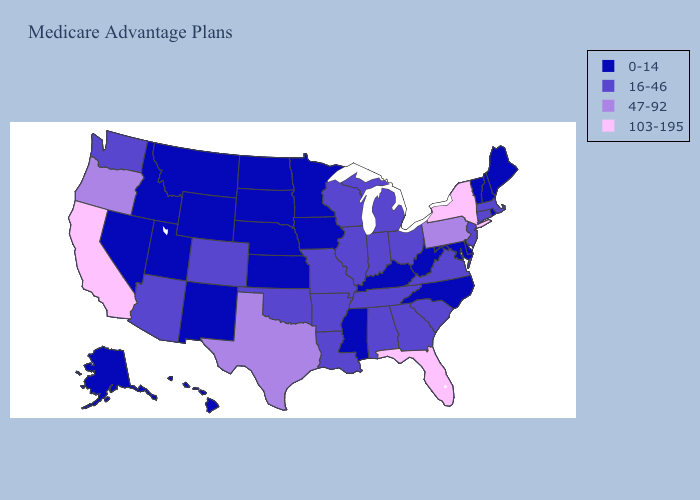Name the states that have a value in the range 103-195?
Answer briefly. California, Florida, New York. Among the states that border Minnesota , does Wisconsin have the highest value?
Answer briefly. Yes. What is the highest value in the USA?
Quick response, please. 103-195. Does Michigan have the lowest value in the USA?
Quick response, please. No. Does the first symbol in the legend represent the smallest category?
Answer briefly. Yes. Name the states that have a value in the range 0-14?
Be succinct. Alaska, Delaware, Hawaii, Iowa, Idaho, Kansas, Kentucky, Maryland, Maine, Minnesota, Mississippi, Montana, North Carolina, North Dakota, Nebraska, New Hampshire, New Mexico, Nevada, Rhode Island, South Dakota, Utah, Vermont, West Virginia, Wyoming. Does Wisconsin have the lowest value in the MidWest?
Write a very short answer. No. Does Alaska have the highest value in the USA?
Give a very brief answer. No. Name the states that have a value in the range 103-195?
Write a very short answer. California, Florida, New York. What is the value of Iowa?
Keep it brief. 0-14. Name the states that have a value in the range 47-92?
Concise answer only. Oregon, Pennsylvania, Texas. What is the lowest value in the USA?
Quick response, please. 0-14. Is the legend a continuous bar?
Quick response, please. No. Name the states that have a value in the range 16-46?
Quick response, please. Alabama, Arkansas, Arizona, Colorado, Connecticut, Georgia, Illinois, Indiana, Louisiana, Massachusetts, Michigan, Missouri, New Jersey, Ohio, Oklahoma, South Carolina, Tennessee, Virginia, Washington, Wisconsin. What is the highest value in the West ?
Be succinct. 103-195. 